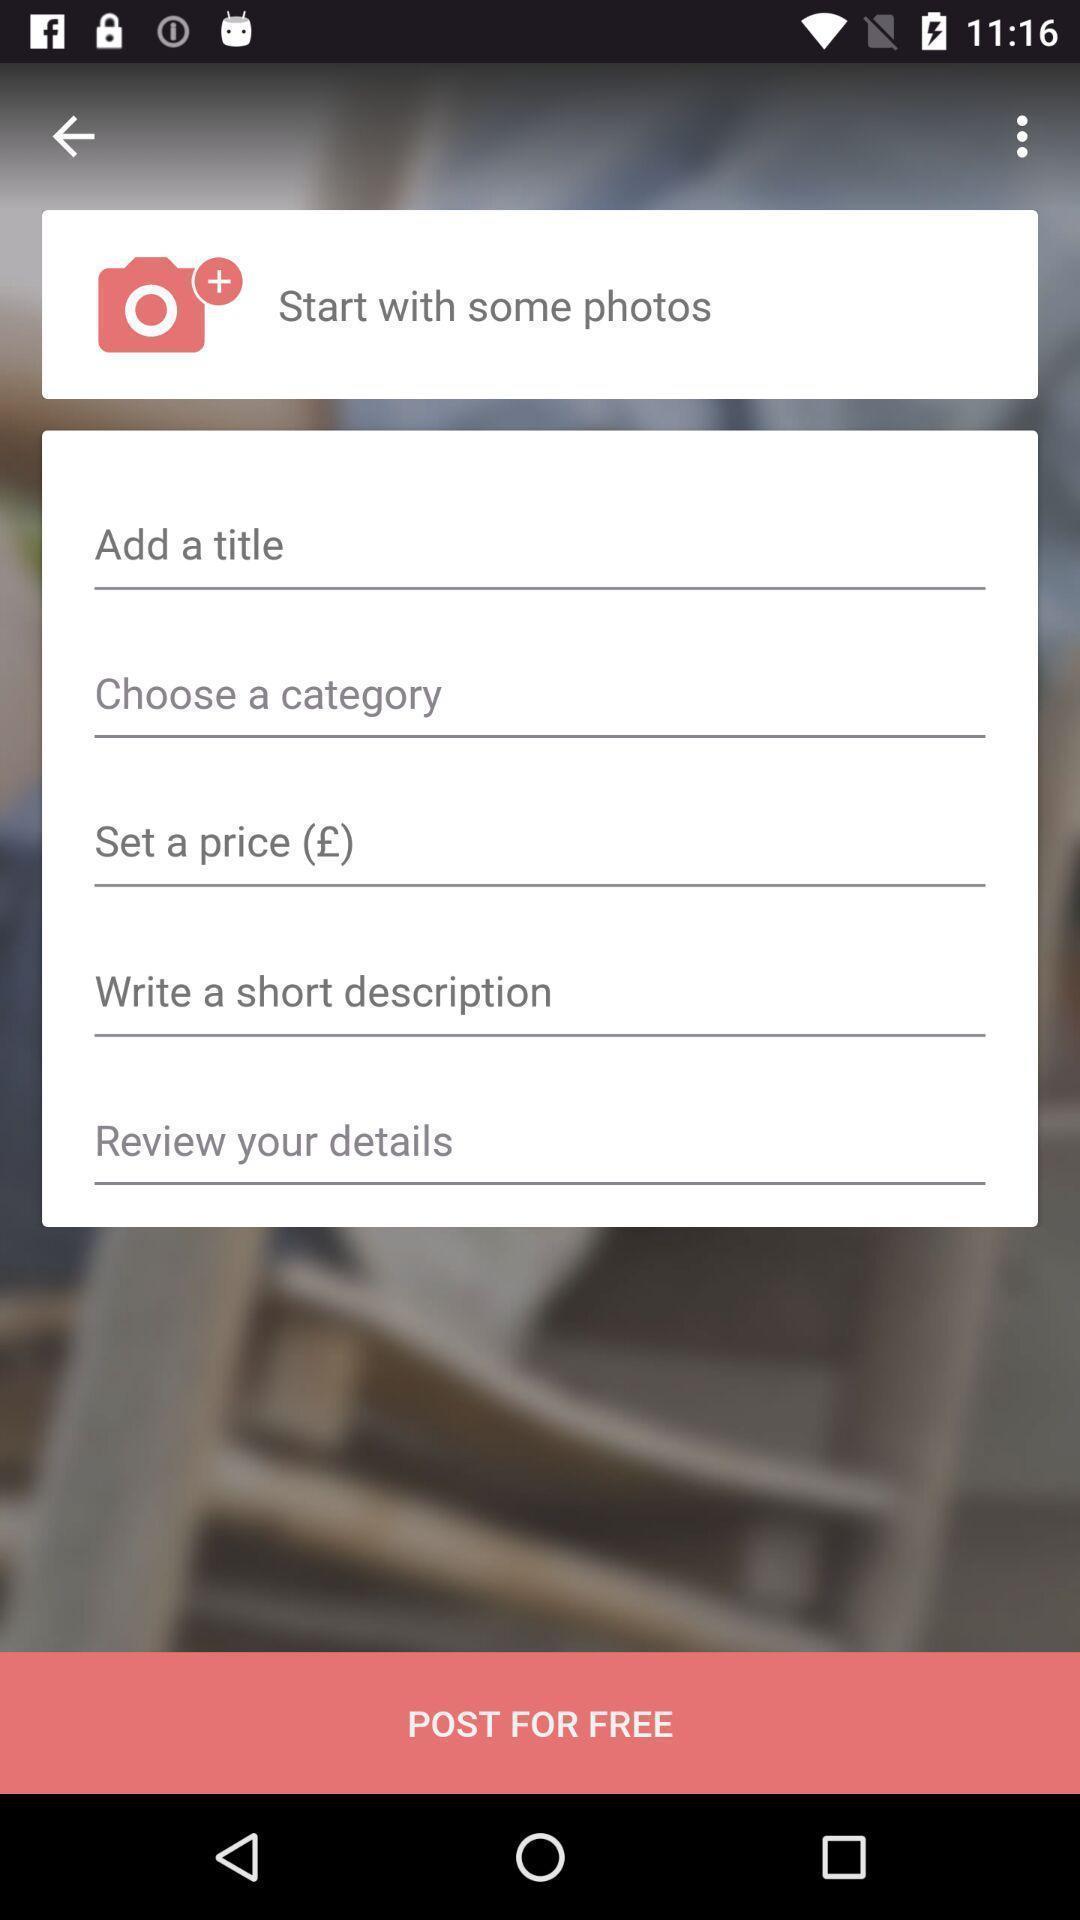Give me a narrative description of this picture. Welcome page to the application with few entry details. 